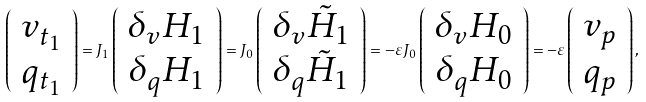Convert formula to latex. <formula><loc_0><loc_0><loc_500><loc_500>\left ( \begin{array} { c } v _ { t _ { 1 } } \\ q _ { t _ { 1 } } \end{array} \right ) = J _ { 1 } \left ( \begin{array} { c } \delta _ { v } H _ { 1 } \\ \delta _ { q } H _ { 1 } \end{array} \right ) = J _ { 0 } \left ( \begin{array} { c } \delta _ { v } \tilde { H } _ { 1 } \\ \delta _ { q } \tilde { H } _ { 1 } \end{array} \right ) = - \varepsilon J _ { 0 } \left ( \begin{array} { c } \delta _ { v } H _ { 0 } \\ \delta _ { q } H _ { 0 } \end{array} \right ) = - \varepsilon \left ( \begin{array} { c } v _ { p } \\ q _ { p } \end{array} \right ) ,</formula> 